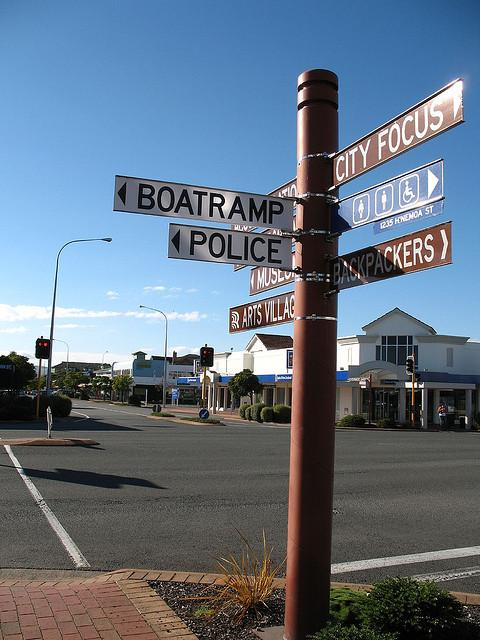What sign should I follow if I have lost my wallet?

Choices:
A) police
B) boatramp
C) city focus
D) backpackers police 